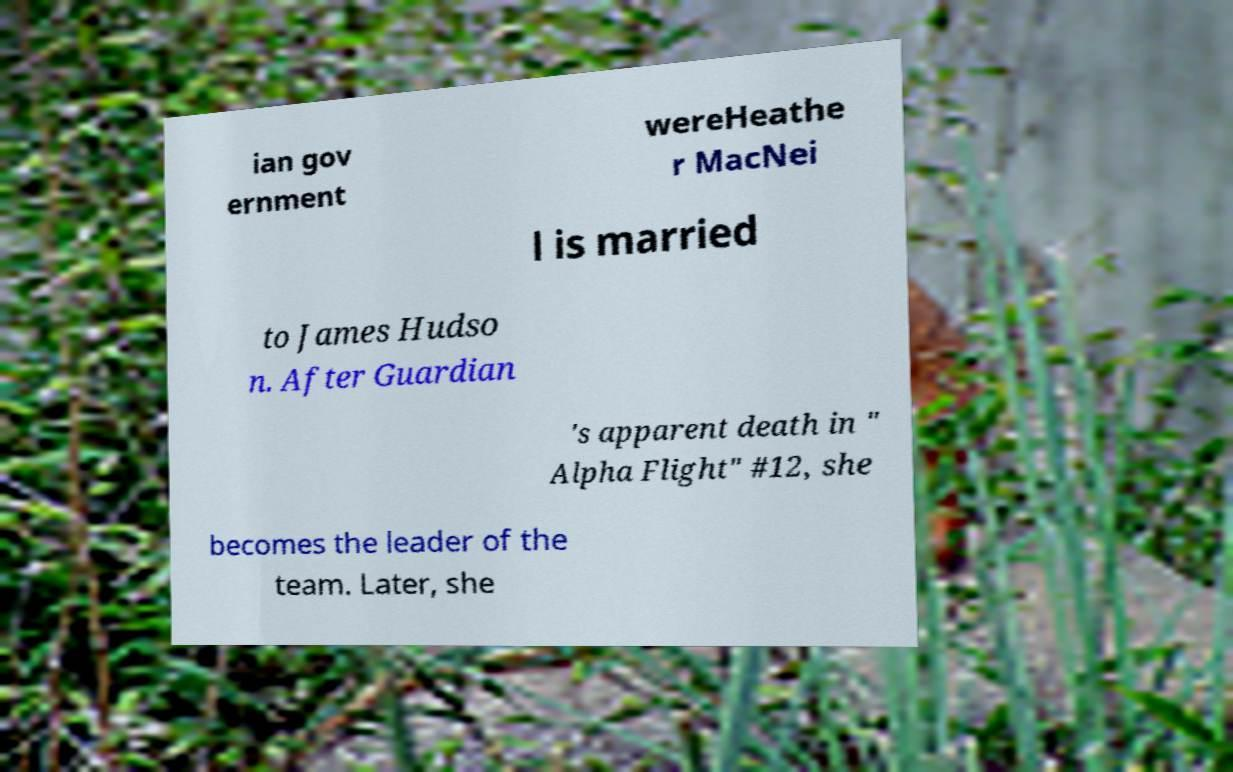There's text embedded in this image that I need extracted. Can you transcribe it verbatim? ian gov ernment wereHeathe r MacNei l is married to James Hudso n. After Guardian 's apparent death in " Alpha Flight" #12, she becomes the leader of the team. Later, she 